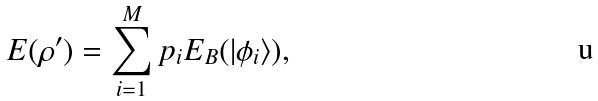Convert formula to latex. <formula><loc_0><loc_0><loc_500><loc_500>E ( \rho ^ { \prime } ) = \sum _ { i = 1 } ^ { M } p _ { i } E _ { B } ( | \phi _ { i } \rangle ) ,</formula> 